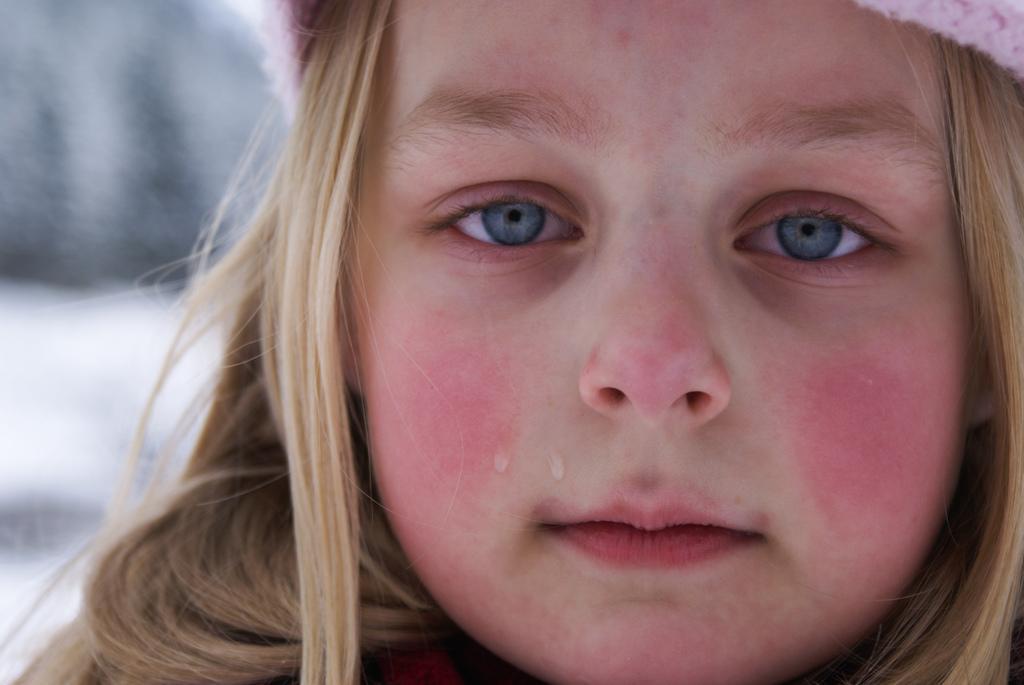Please provide a concise description of this image. This image consists of a girl crying. The background is blurred. 